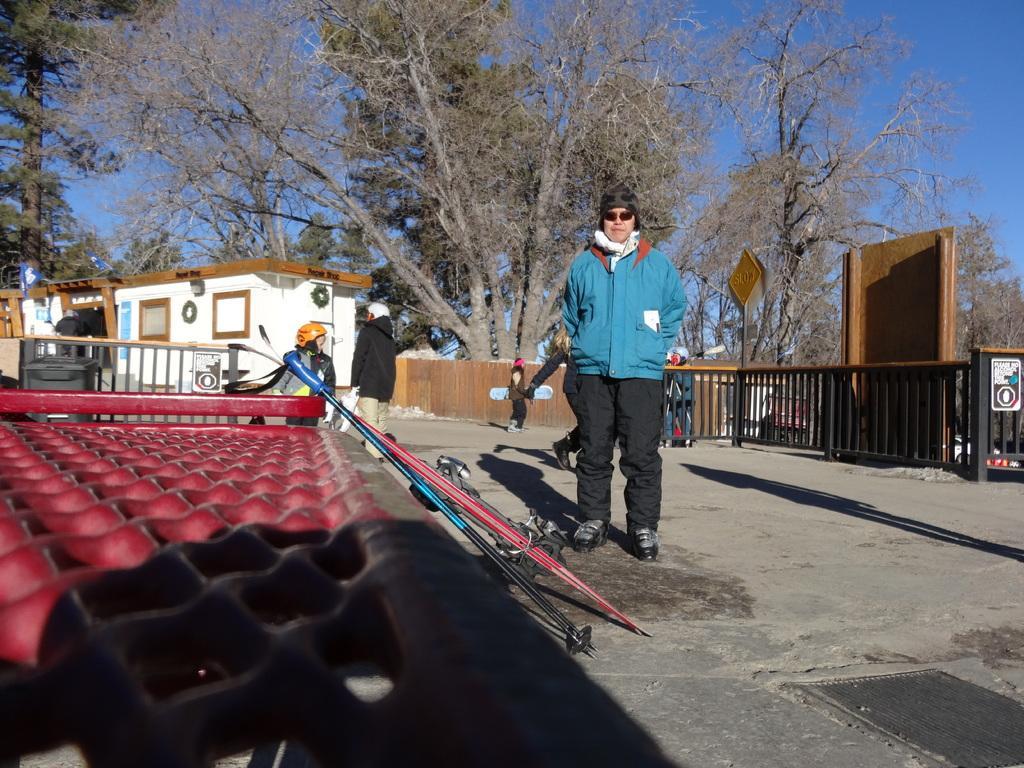Could you give a brief overview of what you see in this image? In this image I can see few people and I can see most of them are wearing jackets. I can also see few of them are wearing caps and few are wearing helmets. In the background I can see view boards, number of trees, a building and the sky. 